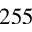<formula> <loc_0><loc_0><loc_500><loc_500>2 5 5</formula> 